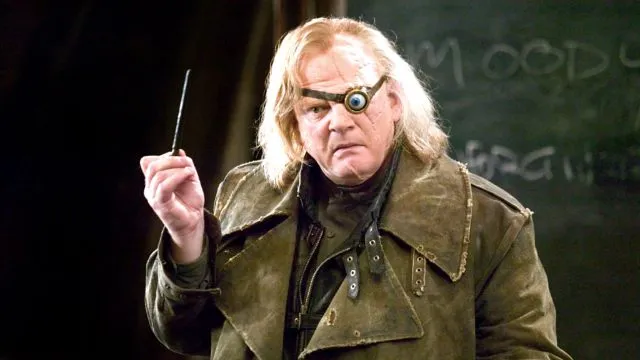What are the key elements in this picture? The image showcases Brendan Gleeson as Alastor 'Mad-Eye' Moody from the Harry Potter series, standing against a dark backdrop that emphasizes his striking costume and props. He wears a long, dark green coat that gives him a mysterious aura. His most distinctive feature is the prosthetic eye, replacing his right eye, fitting for the character's vigilant personality. He holds a wand in his right hand, as if in the midst of casting a spell, adding to the intensity of the scene. This detailed portrayal captures the essence of the magical and intense character from the beloved Harry Potter series. 